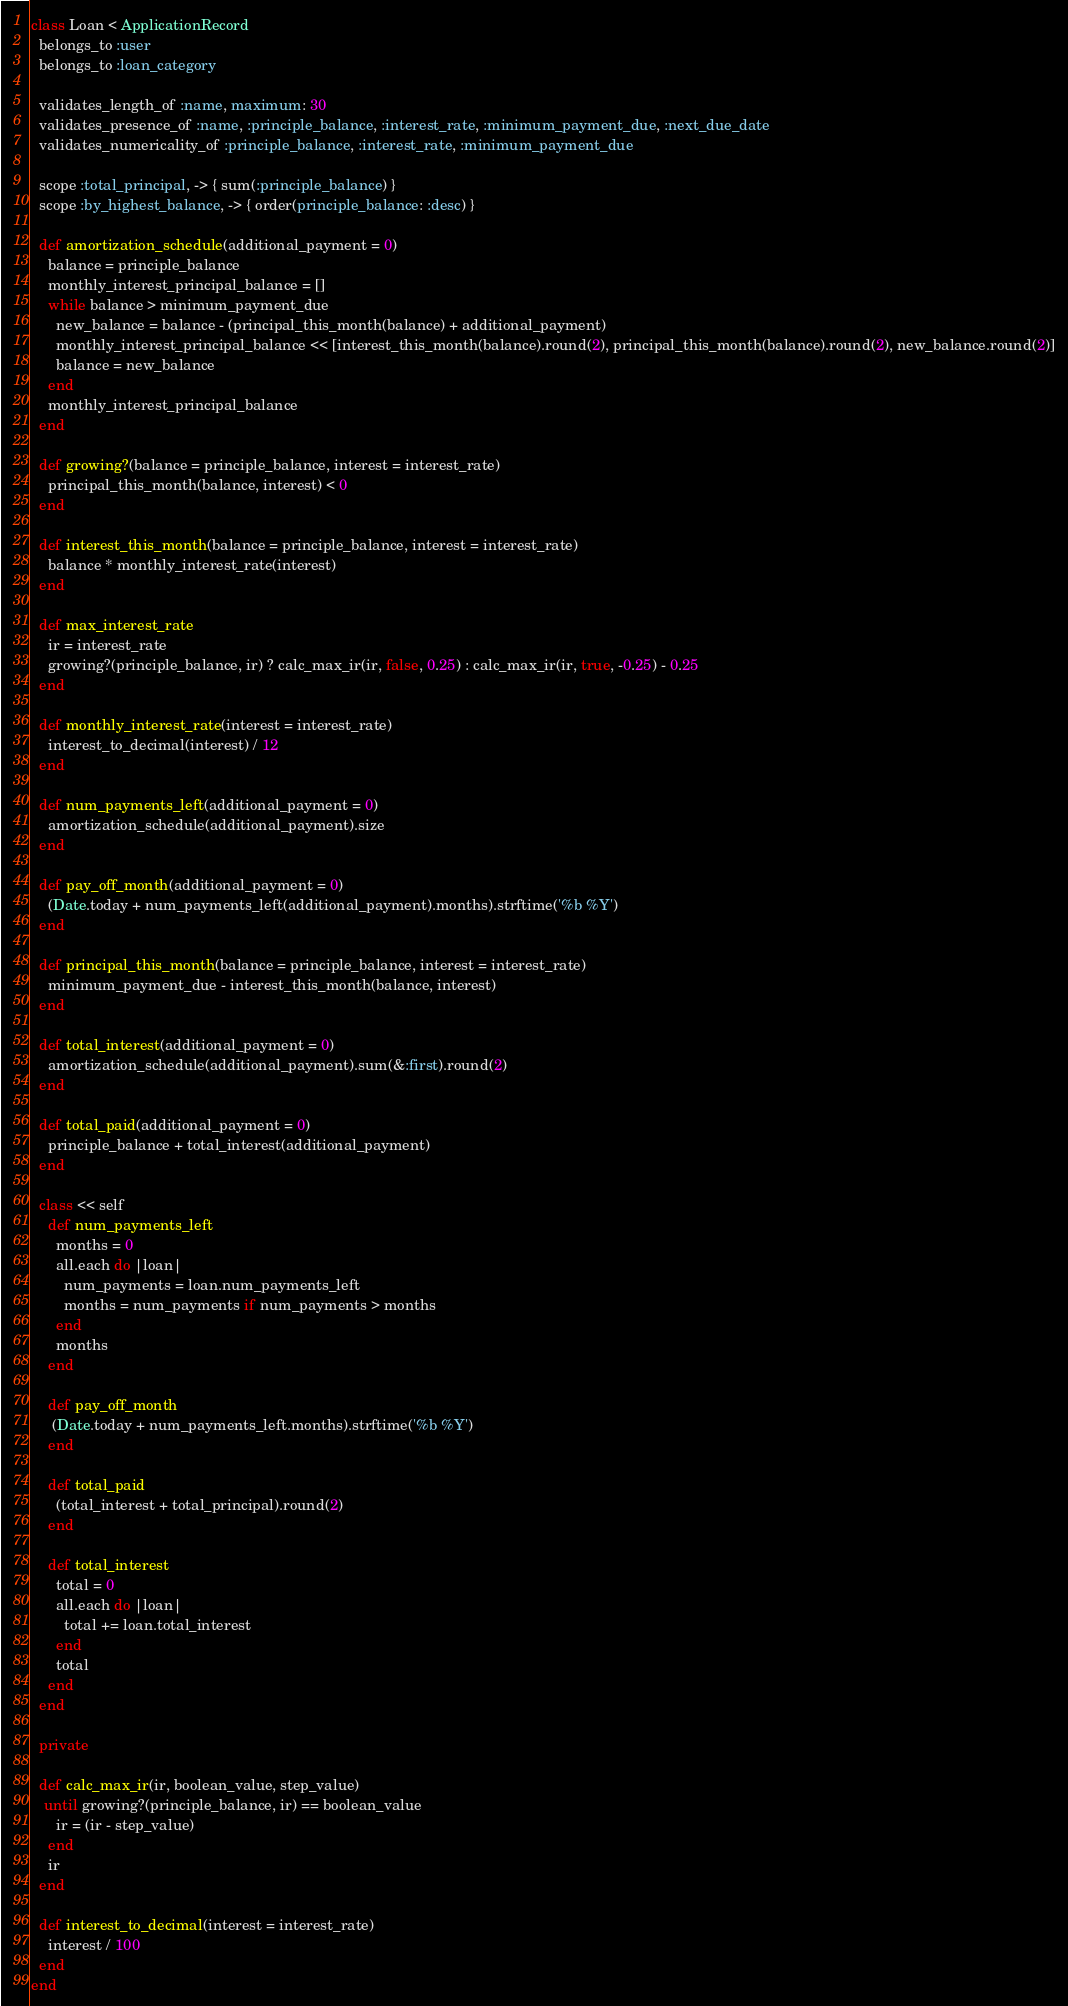<code> <loc_0><loc_0><loc_500><loc_500><_Ruby_>class Loan < ApplicationRecord
  belongs_to :user
  belongs_to :loan_category

  validates_length_of :name, maximum: 30
  validates_presence_of :name, :principle_balance, :interest_rate, :minimum_payment_due, :next_due_date
  validates_numericality_of :principle_balance, :interest_rate, :minimum_payment_due

  scope :total_principal, -> { sum(:principle_balance) }
  scope :by_highest_balance, -> { order(principle_balance: :desc) }

  def amortization_schedule(additional_payment = 0)
    balance = principle_balance
    monthly_interest_principal_balance = []
    while balance > minimum_payment_due
      new_balance = balance - (principal_this_month(balance) + additional_payment)
      monthly_interest_principal_balance << [interest_this_month(balance).round(2), principal_this_month(balance).round(2), new_balance.round(2)]
      balance = new_balance
    end
    monthly_interest_principal_balance
  end

  def growing?(balance = principle_balance, interest = interest_rate)
    principal_this_month(balance, interest) < 0
  end

  def interest_this_month(balance = principle_balance, interest = interest_rate)
    balance * monthly_interest_rate(interest)
  end

  def max_interest_rate
    ir = interest_rate
    growing?(principle_balance, ir) ? calc_max_ir(ir, false, 0.25) : calc_max_ir(ir, true, -0.25) - 0.25
  end

  def monthly_interest_rate(interest = interest_rate)
    interest_to_decimal(interest) / 12
  end

  def num_payments_left(additional_payment = 0)
    amortization_schedule(additional_payment).size
  end

  def pay_off_month(additional_payment = 0)
    (Date.today + num_payments_left(additional_payment).months).strftime('%b %Y')
  end

  def principal_this_month(balance = principle_balance, interest = interest_rate)
    minimum_payment_due - interest_this_month(balance, interest)
  end

  def total_interest(additional_payment = 0)
    amortization_schedule(additional_payment).sum(&:first).round(2)
  end

  def total_paid(additional_payment = 0)
    principle_balance + total_interest(additional_payment)
  end

  class << self
    def num_payments_left
      months = 0
      all.each do |loan|
        num_payments = loan.num_payments_left
        months = num_payments if num_payments > months
      end
      months
    end

    def pay_off_month
     (Date.today + num_payments_left.months).strftime('%b %Y')
    end

    def total_paid
      (total_interest + total_principal).round(2)
    end

    def total_interest
      total = 0
      all.each do |loan|
        total += loan.total_interest
      end
      total
    end
  end

  private

  def calc_max_ir(ir, boolean_value, step_value)
   until growing?(principle_balance, ir) == boolean_value
      ir = (ir - step_value)
    end
    ir
  end

  def interest_to_decimal(interest = interest_rate)
    interest / 100
  end
end
</code> 